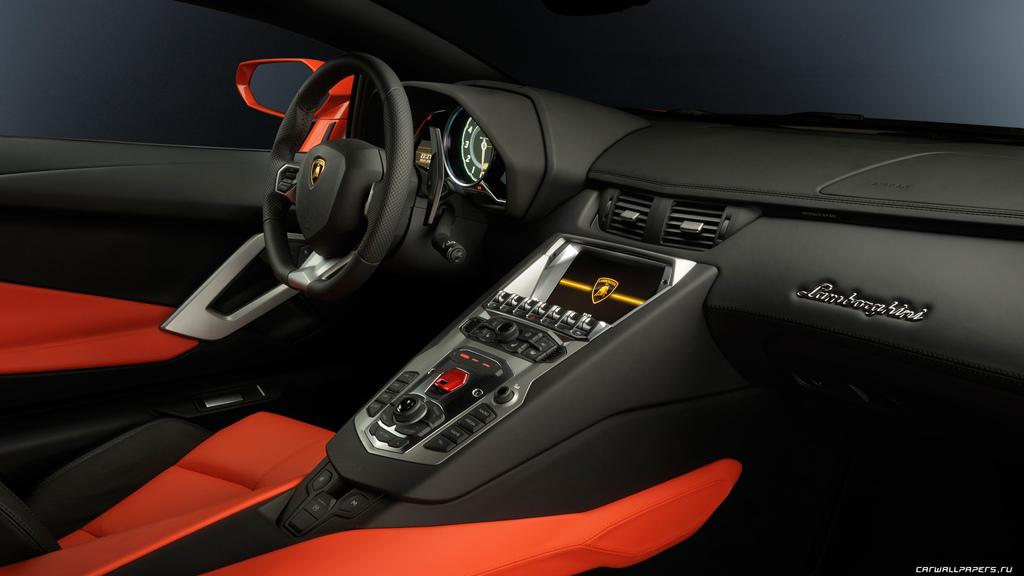What is the setting of the image? The image is taken from inside a car. What can be seen in the front of the car? There is a steering wheel, seats, a music player, and a dashboard in the image. What is the purpose of the glass in the image? The glass is part of the window, which allows the driver to see outside the car. What is the function of the door in the image? The door provides access to the car and can be opened and closed. Can you see a leg hanging out of the window in the image? No, there is no leg hanging out of the window in the image. 